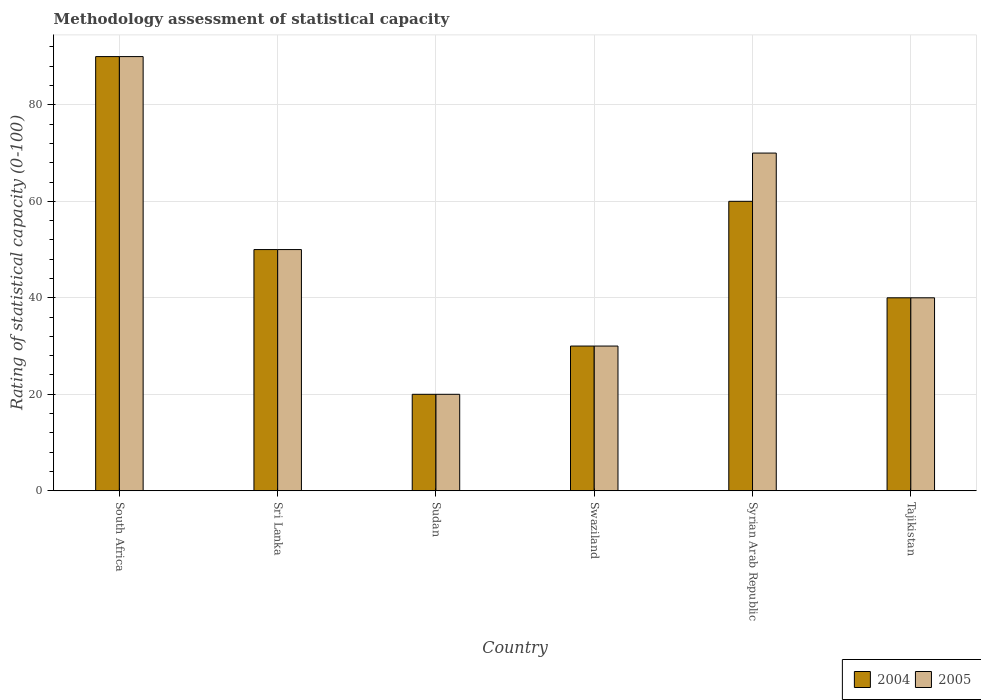How many different coloured bars are there?
Provide a short and direct response. 2. How many groups of bars are there?
Provide a succinct answer. 6. Are the number of bars on each tick of the X-axis equal?
Provide a succinct answer. Yes. How many bars are there on the 4th tick from the left?
Your answer should be very brief. 2. What is the label of the 5th group of bars from the left?
Offer a very short reply. Syrian Arab Republic. What is the rating of statistical capacity in 2005 in Tajikistan?
Offer a terse response. 40. Across all countries, what is the maximum rating of statistical capacity in 2004?
Ensure brevity in your answer.  90. In which country was the rating of statistical capacity in 2005 maximum?
Offer a very short reply. South Africa. In which country was the rating of statistical capacity in 2005 minimum?
Ensure brevity in your answer.  Sudan. What is the total rating of statistical capacity in 2004 in the graph?
Ensure brevity in your answer.  290. What is the difference between the rating of statistical capacity in 2004 in Swaziland and that in Syrian Arab Republic?
Your answer should be very brief. -30. What is the average rating of statistical capacity in 2004 per country?
Provide a succinct answer. 48.33. What is the difference between the rating of statistical capacity of/in 2004 and rating of statistical capacity of/in 2005 in South Africa?
Provide a succinct answer. 0. What is the ratio of the rating of statistical capacity in 2005 in South Africa to that in Tajikistan?
Your answer should be very brief. 2.25. Is the rating of statistical capacity in 2005 in Sri Lanka less than that in Tajikistan?
Make the answer very short. No. Is the difference between the rating of statistical capacity in 2004 in Sudan and Swaziland greater than the difference between the rating of statistical capacity in 2005 in Sudan and Swaziland?
Offer a terse response. No. What is the difference between the highest and the lowest rating of statistical capacity in 2004?
Offer a terse response. 70. Is the sum of the rating of statistical capacity in 2005 in Swaziland and Syrian Arab Republic greater than the maximum rating of statistical capacity in 2004 across all countries?
Ensure brevity in your answer.  Yes. What does the 1st bar from the left in Tajikistan represents?
Keep it short and to the point. 2004. How many bars are there?
Give a very brief answer. 12. Are all the bars in the graph horizontal?
Ensure brevity in your answer.  No. How many countries are there in the graph?
Ensure brevity in your answer.  6. Are the values on the major ticks of Y-axis written in scientific E-notation?
Give a very brief answer. No. What is the title of the graph?
Your response must be concise. Methodology assessment of statistical capacity. What is the label or title of the X-axis?
Make the answer very short. Country. What is the label or title of the Y-axis?
Make the answer very short. Rating of statistical capacity (0-100). What is the Rating of statistical capacity (0-100) in 2005 in South Africa?
Provide a short and direct response. 90. What is the Rating of statistical capacity (0-100) in 2004 in Sri Lanka?
Your answer should be compact. 50. What is the Rating of statistical capacity (0-100) of 2005 in Sri Lanka?
Ensure brevity in your answer.  50. What is the Rating of statistical capacity (0-100) of 2004 in Sudan?
Offer a very short reply. 20. What is the Rating of statistical capacity (0-100) in 2004 in Swaziland?
Keep it short and to the point. 30. What is the Rating of statistical capacity (0-100) in 2005 in Swaziland?
Your answer should be compact. 30. What is the Rating of statistical capacity (0-100) in 2004 in Syrian Arab Republic?
Offer a very short reply. 60. What is the Rating of statistical capacity (0-100) of 2004 in Tajikistan?
Keep it short and to the point. 40. Across all countries, what is the minimum Rating of statistical capacity (0-100) of 2005?
Your answer should be compact. 20. What is the total Rating of statistical capacity (0-100) of 2004 in the graph?
Offer a very short reply. 290. What is the total Rating of statistical capacity (0-100) in 2005 in the graph?
Your answer should be very brief. 300. What is the difference between the Rating of statistical capacity (0-100) in 2004 in South Africa and that in Sri Lanka?
Give a very brief answer. 40. What is the difference between the Rating of statistical capacity (0-100) in 2005 in South Africa and that in Sri Lanka?
Keep it short and to the point. 40. What is the difference between the Rating of statistical capacity (0-100) of 2004 in South Africa and that in Swaziland?
Your answer should be compact. 60. What is the difference between the Rating of statistical capacity (0-100) of 2004 in South Africa and that in Syrian Arab Republic?
Offer a very short reply. 30. What is the difference between the Rating of statistical capacity (0-100) in 2005 in South Africa and that in Syrian Arab Republic?
Offer a very short reply. 20. What is the difference between the Rating of statistical capacity (0-100) in 2005 in South Africa and that in Tajikistan?
Provide a succinct answer. 50. What is the difference between the Rating of statistical capacity (0-100) in 2004 in Sri Lanka and that in Sudan?
Ensure brevity in your answer.  30. What is the difference between the Rating of statistical capacity (0-100) in 2005 in Sri Lanka and that in Sudan?
Offer a very short reply. 30. What is the difference between the Rating of statistical capacity (0-100) in 2004 in Sri Lanka and that in Swaziland?
Provide a short and direct response. 20. What is the difference between the Rating of statistical capacity (0-100) of 2005 in Sri Lanka and that in Swaziland?
Your answer should be compact. 20. What is the difference between the Rating of statistical capacity (0-100) in 2004 in Sri Lanka and that in Syrian Arab Republic?
Make the answer very short. -10. What is the difference between the Rating of statistical capacity (0-100) in 2005 in Sri Lanka and that in Tajikistan?
Ensure brevity in your answer.  10. What is the difference between the Rating of statistical capacity (0-100) in 2004 in Sudan and that in Swaziland?
Offer a very short reply. -10. What is the difference between the Rating of statistical capacity (0-100) of 2005 in Sudan and that in Swaziland?
Give a very brief answer. -10. What is the difference between the Rating of statistical capacity (0-100) of 2004 in Sudan and that in Syrian Arab Republic?
Give a very brief answer. -40. What is the difference between the Rating of statistical capacity (0-100) of 2004 in Sudan and that in Tajikistan?
Keep it short and to the point. -20. What is the difference between the Rating of statistical capacity (0-100) of 2005 in Swaziland and that in Tajikistan?
Offer a very short reply. -10. What is the difference between the Rating of statistical capacity (0-100) in 2005 in Syrian Arab Republic and that in Tajikistan?
Keep it short and to the point. 30. What is the difference between the Rating of statistical capacity (0-100) of 2004 in South Africa and the Rating of statistical capacity (0-100) of 2005 in Sudan?
Offer a terse response. 70. What is the difference between the Rating of statistical capacity (0-100) in 2004 in South Africa and the Rating of statistical capacity (0-100) in 2005 in Tajikistan?
Your answer should be compact. 50. What is the difference between the Rating of statistical capacity (0-100) in 2004 in Sri Lanka and the Rating of statistical capacity (0-100) in 2005 in Syrian Arab Republic?
Your answer should be very brief. -20. What is the difference between the Rating of statistical capacity (0-100) of 2004 in Sudan and the Rating of statistical capacity (0-100) of 2005 in Syrian Arab Republic?
Your answer should be very brief. -50. What is the difference between the Rating of statistical capacity (0-100) of 2004 in Sudan and the Rating of statistical capacity (0-100) of 2005 in Tajikistan?
Give a very brief answer. -20. What is the difference between the Rating of statistical capacity (0-100) of 2004 in Swaziland and the Rating of statistical capacity (0-100) of 2005 in Tajikistan?
Offer a terse response. -10. What is the average Rating of statistical capacity (0-100) in 2004 per country?
Your answer should be compact. 48.33. What is the difference between the Rating of statistical capacity (0-100) of 2004 and Rating of statistical capacity (0-100) of 2005 in South Africa?
Offer a terse response. 0. What is the difference between the Rating of statistical capacity (0-100) in 2004 and Rating of statistical capacity (0-100) in 2005 in Sudan?
Provide a short and direct response. 0. What is the difference between the Rating of statistical capacity (0-100) of 2004 and Rating of statistical capacity (0-100) of 2005 in Swaziland?
Keep it short and to the point. 0. What is the difference between the Rating of statistical capacity (0-100) of 2004 and Rating of statistical capacity (0-100) of 2005 in Tajikistan?
Provide a succinct answer. 0. What is the ratio of the Rating of statistical capacity (0-100) of 2004 in South Africa to that in Sri Lanka?
Your answer should be very brief. 1.8. What is the ratio of the Rating of statistical capacity (0-100) of 2005 in South Africa to that in Sri Lanka?
Provide a short and direct response. 1.8. What is the ratio of the Rating of statistical capacity (0-100) of 2005 in South Africa to that in Sudan?
Make the answer very short. 4.5. What is the ratio of the Rating of statistical capacity (0-100) of 2004 in South Africa to that in Swaziland?
Your response must be concise. 3. What is the ratio of the Rating of statistical capacity (0-100) in 2005 in South Africa to that in Syrian Arab Republic?
Your answer should be compact. 1.29. What is the ratio of the Rating of statistical capacity (0-100) of 2004 in South Africa to that in Tajikistan?
Provide a short and direct response. 2.25. What is the ratio of the Rating of statistical capacity (0-100) of 2005 in South Africa to that in Tajikistan?
Your answer should be very brief. 2.25. What is the ratio of the Rating of statistical capacity (0-100) in 2004 in Sri Lanka to that in Syrian Arab Republic?
Offer a terse response. 0.83. What is the ratio of the Rating of statistical capacity (0-100) in 2005 in Sri Lanka to that in Tajikistan?
Offer a very short reply. 1.25. What is the ratio of the Rating of statistical capacity (0-100) in 2004 in Sudan to that in Swaziland?
Provide a short and direct response. 0.67. What is the ratio of the Rating of statistical capacity (0-100) of 2005 in Sudan to that in Swaziland?
Make the answer very short. 0.67. What is the ratio of the Rating of statistical capacity (0-100) in 2004 in Sudan to that in Syrian Arab Republic?
Provide a short and direct response. 0.33. What is the ratio of the Rating of statistical capacity (0-100) in 2005 in Sudan to that in Syrian Arab Republic?
Your response must be concise. 0.29. What is the ratio of the Rating of statistical capacity (0-100) of 2004 in Sudan to that in Tajikistan?
Give a very brief answer. 0.5. What is the ratio of the Rating of statistical capacity (0-100) of 2005 in Sudan to that in Tajikistan?
Make the answer very short. 0.5. What is the ratio of the Rating of statistical capacity (0-100) of 2005 in Swaziland to that in Syrian Arab Republic?
Make the answer very short. 0.43. What is the ratio of the Rating of statistical capacity (0-100) of 2004 in Swaziland to that in Tajikistan?
Your response must be concise. 0.75. What is the ratio of the Rating of statistical capacity (0-100) in 2005 in Syrian Arab Republic to that in Tajikistan?
Your answer should be compact. 1.75. What is the difference between the highest and the second highest Rating of statistical capacity (0-100) in 2004?
Keep it short and to the point. 30. What is the difference between the highest and the second highest Rating of statistical capacity (0-100) of 2005?
Keep it short and to the point. 20. What is the difference between the highest and the lowest Rating of statistical capacity (0-100) in 2005?
Your answer should be very brief. 70. 